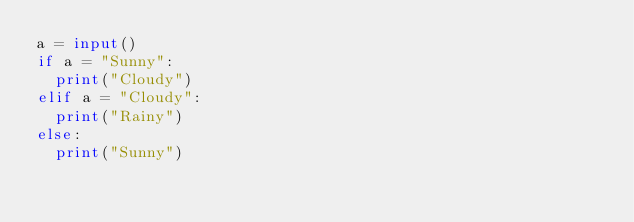Convert code to text. <code><loc_0><loc_0><loc_500><loc_500><_Python_>a = input()
if a = "Sunny":
  print("Cloudy")
elif a = "Cloudy":
  print("Rainy")
else:
  print("Sunny")</code> 